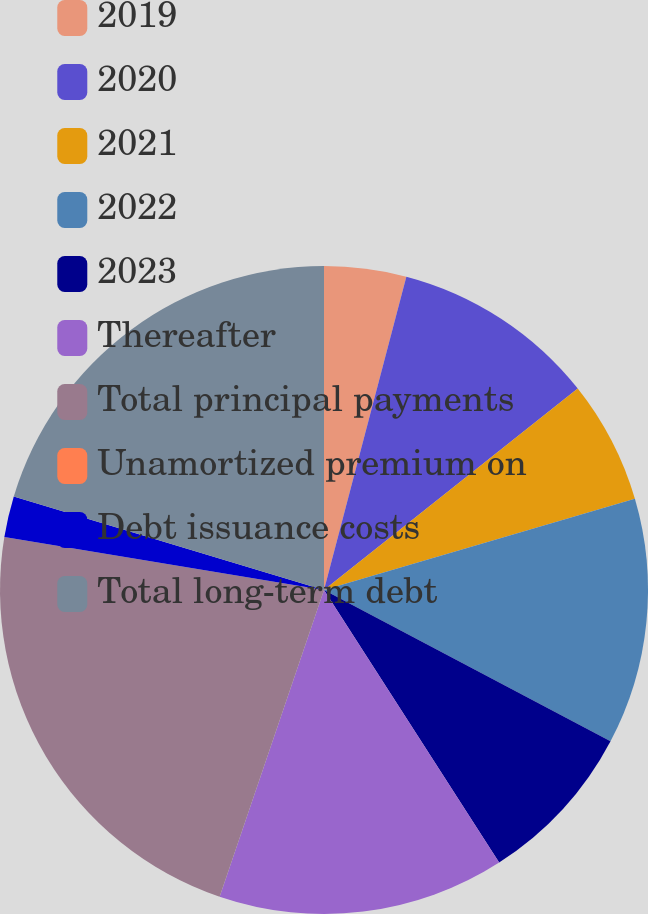Convert chart to OTSL. <chart><loc_0><loc_0><loc_500><loc_500><pie_chart><fcel>2019<fcel>2020<fcel>2021<fcel>2022<fcel>2023<fcel>Thereafter<fcel>Total principal payments<fcel>Unamortized premium on<fcel>Debt issuance costs<fcel>Total long-term debt<nl><fcel>4.09%<fcel>10.23%<fcel>6.14%<fcel>12.27%<fcel>8.18%<fcel>14.31%<fcel>22.39%<fcel>0.0%<fcel>2.05%<fcel>20.34%<nl></chart> 